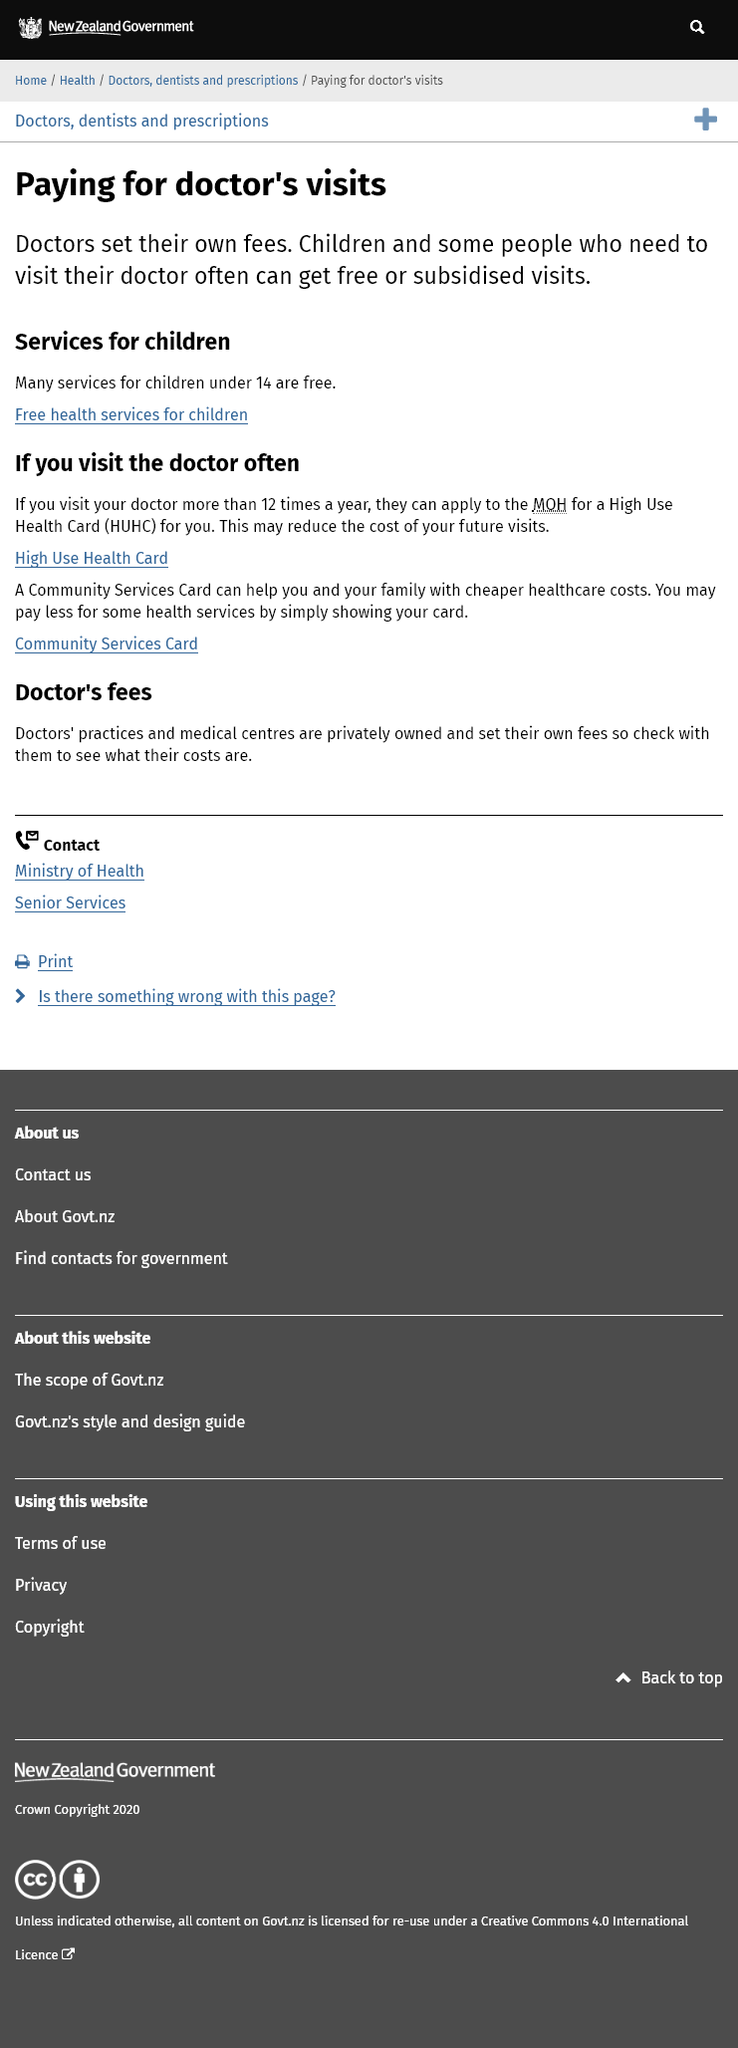Draw attention to some important aspects in this diagram. High Use Health Card is an acronym that stands for HUHC, representing the increasing demand for accessible and affordable healthcare services in our society. Children under 14 years of age are eligible to receive many services for free. Two cards, the High Use Health Card and the Community Services Card, can significantly reduce the costs of healthcare for eligible individuals, providing access to essential services and support. 